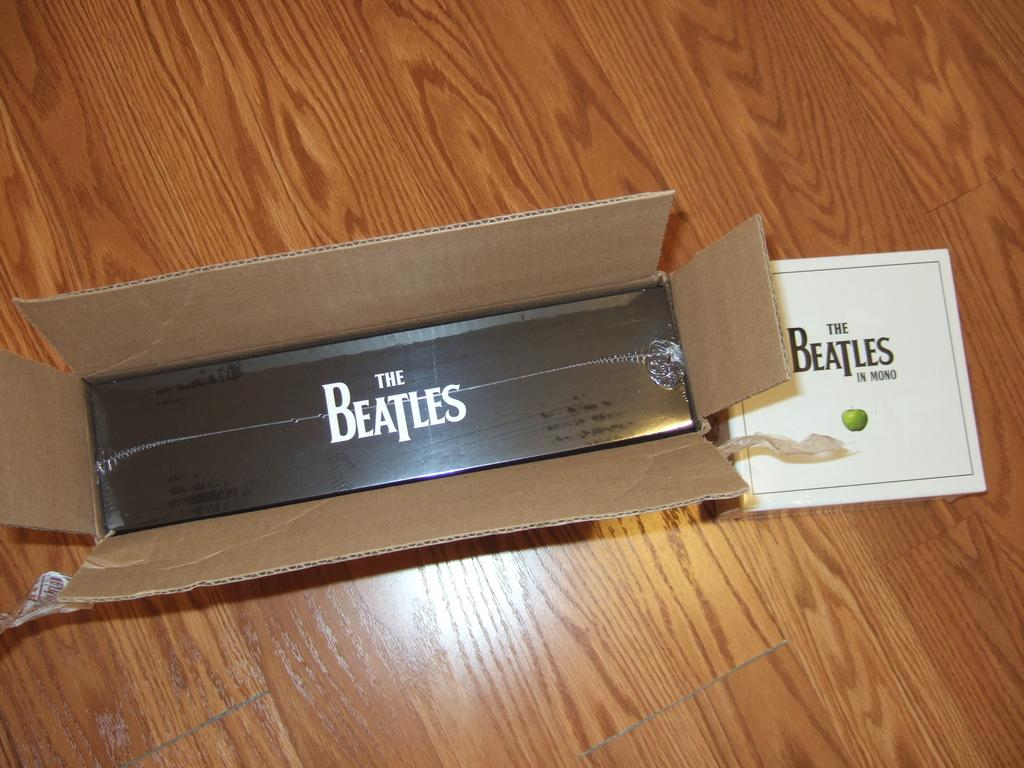<image>
Describe the image concisely. Two Beatles products are on the floor, one of which is in mono. 